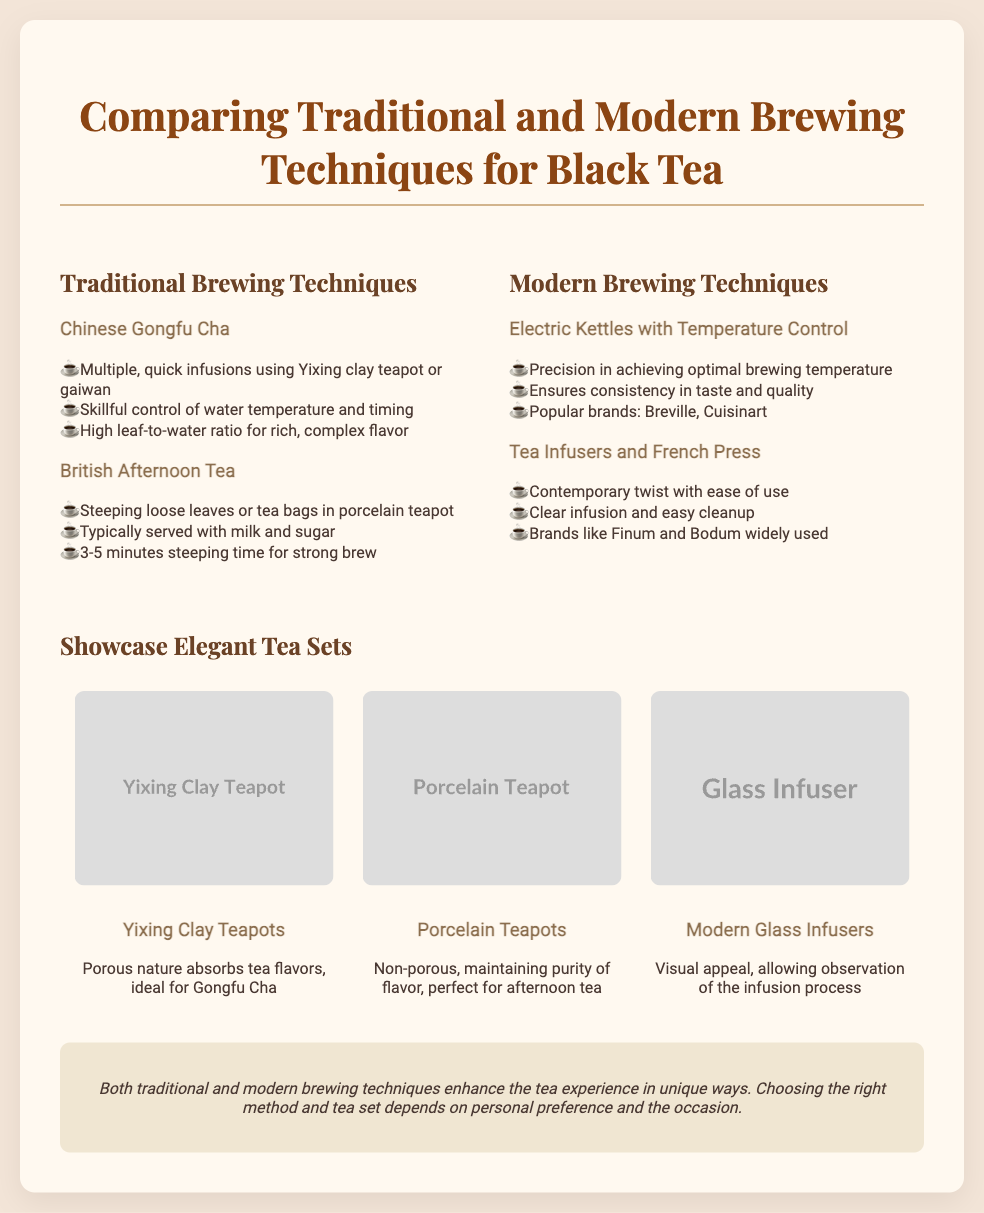What are the two traditional brewing techniques mentioned? The document highlights the Chinese Gongfu Cha and British Afternoon Tea as traditional brewing techniques.
Answer: Chinese Gongfu Cha, British Afternoon Tea What is one feature of Chinese Gongfu Cha? The document states that Chinese Gongfu Cha involves multiple quick infusions using an Yixing clay teapot or gaiwan.
Answer: Multiple, quick infusions What is the typical steeping time for British Afternoon Tea? According to the slide, British Afternoon Tea typically has a steeping time of 3-5 minutes for a strong brew.
Answer: 3-5 minutes What is a modern brewing technique mentioned for achieving optimal brewing temperature? The document lists electric kettles with temperature control as a modern brewing technique for precision in temperature.
Answer: Electric kettles with temperature control Which brand is associated with electric kettles in the document? The document mentions Breville and Cuisinart as popular brands for electric kettles.
Answer: Breville, Cuisinart Which type of tea set is ideal for Gongfu Cha? The slide indicates that Yixing clay teapots are ideal due to their porous nature that absorbs tea flavors.
Answer: Yixing Clay Teapots What aspect of modern glass infusers is highlighted in the presentation? The presentation highlights the visual appeal and the ability to observe the infusion process as a key aspect of modern glass infusers.
Answer: Visual appeal Which type of teapot is perfect for afternoon tea? The document states that porcelain teapots are perfect for maintaining the purity of flavor during afternoon tea.
Answer: Porcelain Teapots What is the conclusion about brewing techniques? The conclusion emphasizes that both traditional and modern brewing techniques enhance the tea experience in unique ways.
Answer: Enhance the tea experience in unique ways 